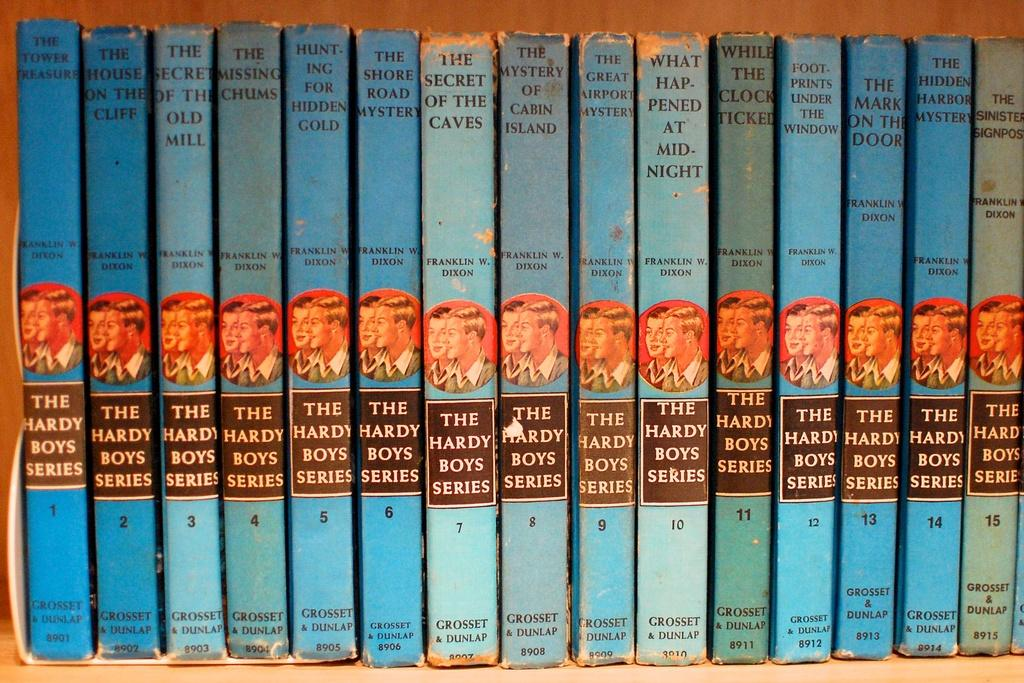<image>
Offer a succinct explanation of the picture presented. A set of books from The Hardy Boys Series is lined up on a shelf. 